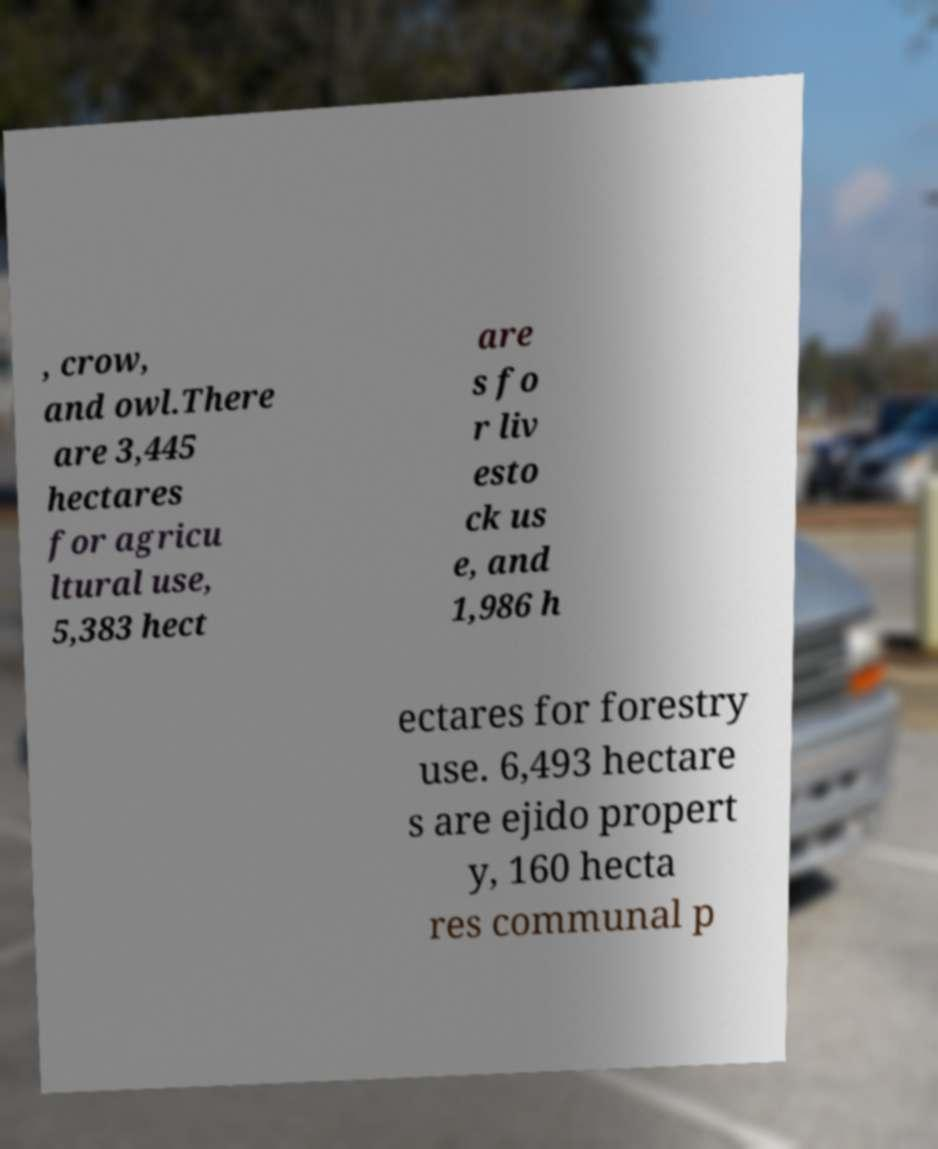Could you assist in decoding the text presented in this image and type it out clearly? , crow, and owl.There are 3,445 hectares for agricu ltural use, 5,383 hect are s fo r liv esto ck us e, and 1,986 h ectares for forestry use. 6,493 hectare s are ejido propert y, 160 hecta res communal p 